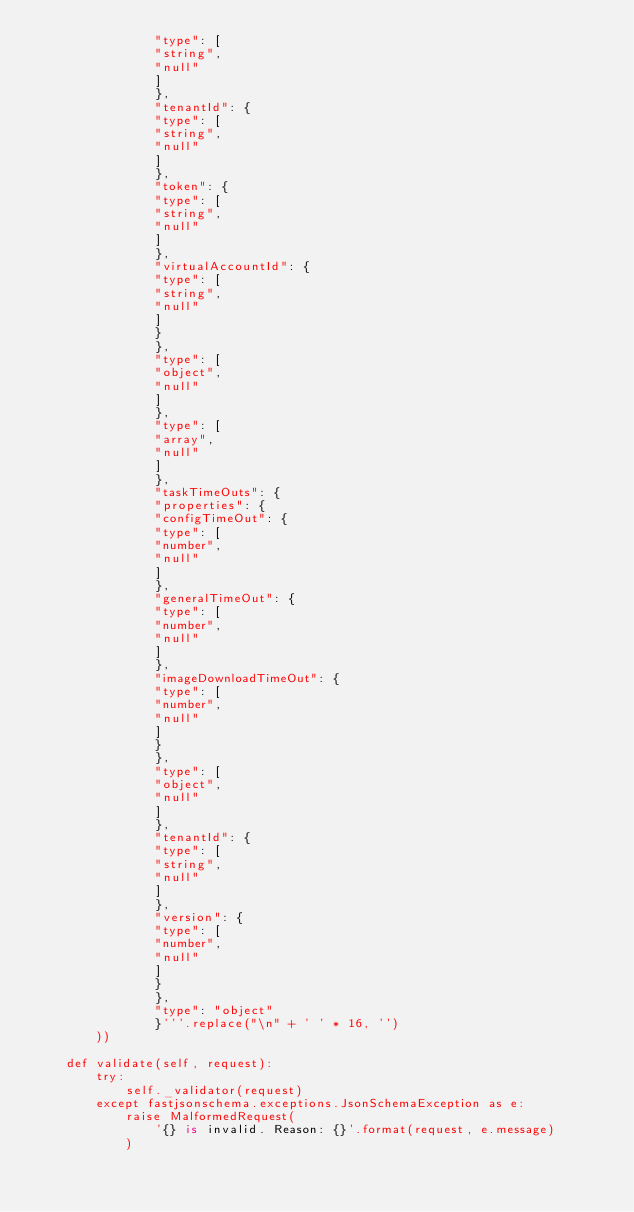Convert code to text. <code><loc_0><loc_0><loc_500><loc_500><_Python_>                "type": [
                "string",
                "null"
                ]
                },
                "tenantId": {
                "type": [
                "string",
                "null"
                ]
                },
                "token": {
                "type": [
                "string",
                "null"
                ]
                },
                "virtualAccountId": {
                "type": [
                "string",
                "null"
                ]
                }
                },
                "type": [
                "object",
                "null"
                ]
                },
                "type": [
                "array",
                "null"
                ]
                },
                "taskTimeOuts": {
                "properties": {
                "configTimeOut": {
                "type": [
                "number",
                "null"
                ]
                },
                "generalTimeOut": {
                "type": [
                "number",
                "null"
                ]
                },
                "imageDownloadTimeOut": {
                "type": [
                "number",
                "null"
                ]
                }
                },
                "type": [
                "object",
                "null"
                ]
                },
                "tenantId": {
                "type": [
                "string",
                "null"
                ]
                },
                "version": {
                "type": [
                "number",
                "null"
                ]
                }
                },
                "type": "object"
                }'''.replace("\n" + ' ' * 16, '')
        ))

    def validate(self, request):
        try:
            self._validator(request)
        except fastjsonschema.exceptions.JsonSchemaException as e:
            raise MalformedRequest(
                '{} is invalid. Reason: {}'.format(request, e.message)
            )
</code> 